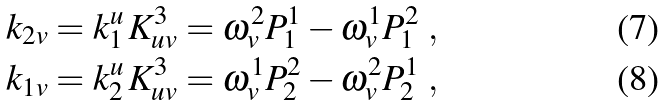<formula> <loc_0><loc_0><loc_500><loc_500>& k _ { 2 v } = k ^ { u } _ { 1 } \, K _ { u v } ^ { 3 } = \omega ^ { 2 } _ { v } P ^ { 1 } _ { 1 } - \omega ^ { 1 } _ { v } P ^ { 2 } _ { 1 } \ , \\ & k _ { 1 v } = k ^ { u } _ { 2 } \, K _ { u v } ^ { 3 } = \omega ^ { 1 } _ { v } P ^ { 2 } _ { 2 } - \omega ^ { 2 } _ { v } P ^ { 1 } _ { 2 } \ ,</formula> 